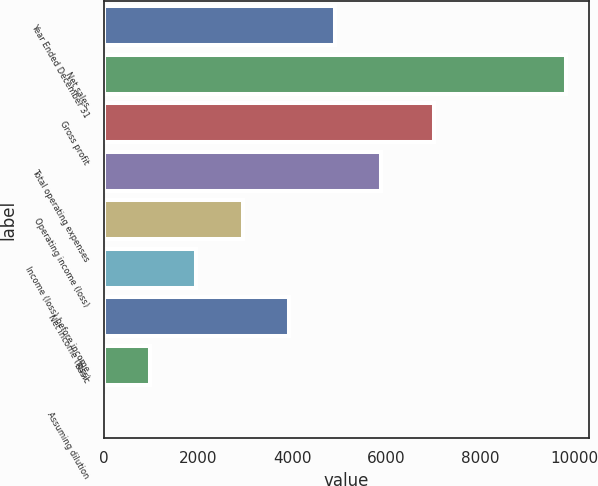<chart> <loc_0><loc_0><loc_500><loc_500><bar_chart><fcel>Year Ended December 31<fcel>Net sales<fcel>Gross profit<fcel>Total operating expenses<fcel>Operating income (loss)<fcel>Income (loss) before income<fcel>Net income (loss)<fcel>Basic<fcel>Assuming dilution<nl><fcel>4912.09<fcel>9823<fcel>7011<fcel>5894.27<fcel>2947.73<fcel>1965.55<fcel>3929.91<fcel>983.37<fcel>1.19<nl></chart> 